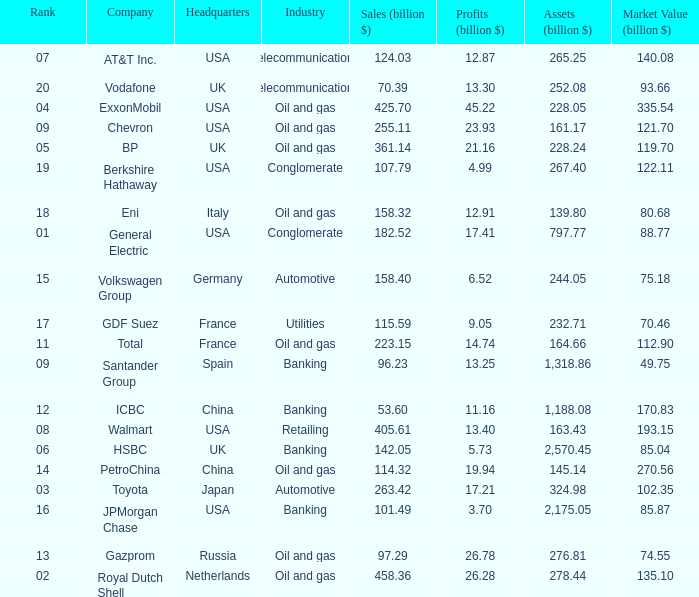Name the lowest Market Value (billion $) which has Assets (billion $) larger than 276.81, and a Company of toyota, and Profits (billion $) larger than 17.21? None. 